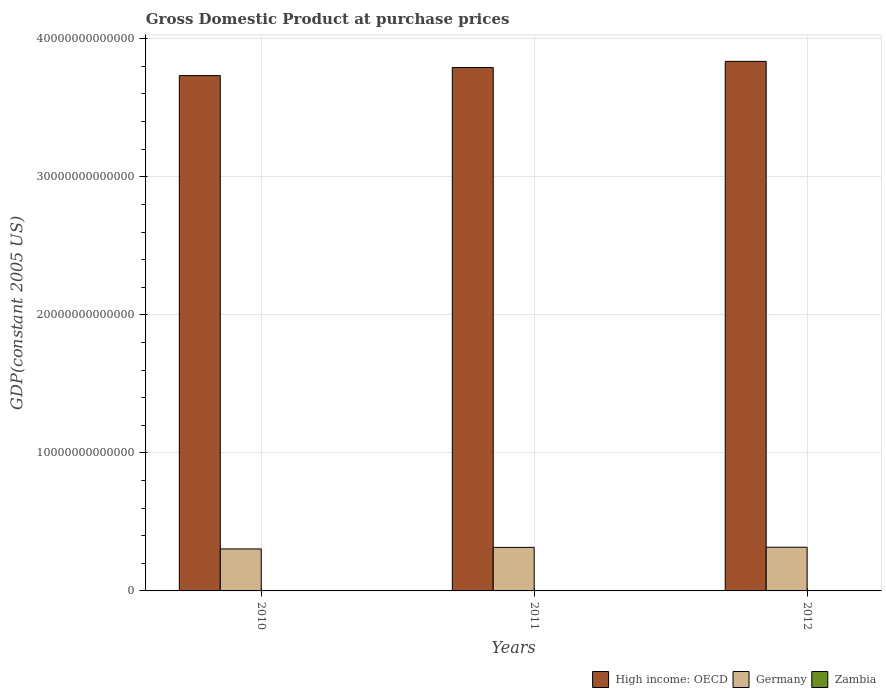How many different coloured bars are there?
Offer a very short reply. 3. Are the number of bars on each tick of the X-axis equal?
Give a very brief answer. Yes. What is the label of the 3rd group of bars from the left?
Your answer should be compact. 2012. In how many cases, is the number of bars for a given year not equal to the number of legend labels?
Offer a very short reply. 0. What is the GDP at purchase prices in Zambia in 2012?
Make the answer very short. 1.44e+1. Across all years, what is the maximum GDP at purchase prices in Zambia?
Provide a succinct answer. 1.44e+1. Across all years, what is the minimum GDP at purchase prices in Zambia?
Offer a terse response. 1.26e+1. What is the total GDP at purchase prices in High income: OECD in the graph?
Your answer should be very brief. 1.14e+14. What is the difference between the GDP at purchase prices in Germany in 2010 and that in 2011?
Your answer should be compact. -1.11e+11. What is the difference between the GDP at purchase prices in High income: OECD in 2011 and the GDP at purchase prices in Germany in 2012?
Provide a short and direct response. 3.48e+13. What is the average GDP at purchase prices in Zambia per year?
Your response must be concise. 1.35e+1. In the year 2011, what is the difference between the GDP at purchase prices in Germany and GDP at purchase prices in Zambia?
Ensure brevity in your answer.  3.14e+12. What is the ratio of the GDP at purchase prices in Germany in 2010 to that in 2012?
Offer a terse response. 0.96. Is the difference between the GDP at purchase prices in Germany in 2010 and 2011 greater than the difference between the GDP at purchase prices in Zambia in 2010 and 2011?
Give a very brief answer. No. What is the difference between the highest and the second highest GDP at purchase prices in Zambia?
Offer a terse response. 9.05e+08. What is the difference between the highest and the lowest GDP at purchase prices in High income: OECD?
Provide a short and direct response. 1.03e+12. Is the sum of the GDP at purchase prices in High income: OECD in 2011 and 2012 greater than the maximum GDP at purchase prices in Germany across all years?
Keep it short and to the point. Yes. What does the 2nd bar from the left in 2012 represents?
Provide a short and direct response. Germany. What does the 1st bar from the right in 2011 represents?
Offer a very short reply. Zambia. What is the difference between two consecutive major ticks on the Y-axis?
Provide a short and direct response. 1.00e+13. Does the graph contain grids?
Your answer should be very brief. Yes. Where does the legend appear in the graph?
Offer a terse response. Bottom right. How are the legend labels stacked?
Your answer should be very brief. Horizontal. What is the title of the graph?
Provide a short and direct response. Gross Domestic Product at purchase prices. What is the label or title of the Y-axis?
Make the answer very short. GDP(constant 2005 US). What is the GDP(constant 2005 US) in High income: OECD in 2010?
Ensure brevity in your answer.  3.73e+13. What is the GDP(constant 2005 US) in Germany in 2010?
Offer a terse response. 3.04e+12. What is the GDP(constant 2005 US) in Zambia in 2010?
Keep it short and to the point. 1.26e+1. What is the GDP(constant 2005 US) of High income: OECD in 2011?
Keep it short and to the point. 3.79e+13. What is the GDP(constant 2005 US) of Germany in 2011?
Your response must be concise. 3.15e+12. What is the GDP(constant 2005 US) of Zambia in 2011?
Keep it short and to the point. 1.34e+1. What is the GDP(constant 2005 US) of High income: OECD in 2012?
Offer a terse response. 3.84e+13. What is the GDP(constant 2005 US) in Germany in 2012?
Your answer should be very brief. 3.17e+12. What is the GDP(constant 2005 US) in Zambia in 2012?
Offer a terse response. 1.44e+1. Across all years, what is the maximum GDP(constant 2005 US) in High income: OECD?
Keep it short and to the point. 3.84e+13. Across all years, what is the maximum GDP(constant 2005 US) of Germany?
Give a very brief answer. 3.17e+12. Across all years, what is the maximum GDP(constant 2005 US) in Zambia?
Offer a very short reply. 1.44e+1. Across all years, what is the minimum GDP(constant 2005 US) in High income: OECD?
Provide a succinct answer. 3.73e+13. Across all years, what is the minimum GDP(constant 2005 US) of Germany?
Offer a very short reply. 3.04e+12. Across all years, what is the minimum GDP(constant 2005 US) in Zambia?
Ensure brevity in your answer.  1.26e+1. What is the total GDP(constant 2005 US) of High income: OECD in the graph?
Make the answer very short. 1.14e+14. What is the total GDP(constant 2005 US) of Germany in the graph?
Your response must be concise. 9.36e+12. What is the total GDP(constant 2005 US) of Zambia in the graph?
Your response must be concise. 4.05e+1. What is the difference between the GDP(constant 2005 US) in High income: OECD in 2010 and that in 2011?
Your response must be concise. -5.88e+11. What is the difference between the GDP(constant 2005 US) in Germany in 2010 and that in 2011?
Provide a short and direct response. -1.11e+11. What is the difference between the GDP(constant 2005 US) of Zambia in 2010 and that in 2011?
Your answer should be compact. -8.02e+08. What is the difference between the GDP(constant 2005 US) of High income: OECD in 2010 and that in 2012?
Ensure brevity in your answer.  -1.03e+12. What is the difference between the GDP(constant 2005 US) in Germany in 2010 and that in 2012?
Provide a succinct answer. -1.24e+11. What is the difference between the GDP(constant 2005 US) of Zambia in 2010 and that in 2012?
Provide a succinct answer. -1.71e+09. What is the difference between the GDP(constant 2005 US) in High income: OECD in 2011 and that in 2012?
Keep it short and to the point. -4.46e+11. What is the difference between the GDP(constant 2005 US) in Germany in 2011 and that in 2012?
Offer a terse response. -1.28e+1. What is the difference between the GDP(constant 2005 US) of Zambia in 2011 and that in 2012?
Your response must be concise. -9.05e+08. What is the difference between the GDP(constant 2005 US) of High income: OECD in 2010 and the GDP(constant 2005 US) of Germany in 2011?
Provide a succinct answer. 3.42e+13. What is the difference between the GDP(constant 2005 US) of High income: OECD in 2010 and the GDP(constant 2005 US) of Zambia in 2011?
Offer a terse response. 3.73e+13. What is the difference between the GDP(constant 2005 US) in Germany in 2010 and the GDP(constant 2005 US) in Zambia in 2011?
Provide a succinct answer. 3.03e+12. What is the difference between the GDP(constant 2005 US) in High income: OECD in 2010 and the GDP(constant 2005 US) in Germany in 2012?
Offer a very short reply. 3.42e+13. What is the difference between the GDP(constant 2005 US) of High income: OECD in 2010 and the GDP(constant 2005 US) of Zambia in 2012?
Ensure brevity in your answer.  3.73e+13. What is the difference between the GDP(constant 2005 US) in Germany in 2010 and the GDP(constant 2005 US) in Zambia in 2012?
Your answer should be compact. 3.03e+12. What is the difference between the GDP(constant 2005 US) of High income: OECD in 2011 and the GDP(constant 2005 US) of Germany in 2012?
Ensure brevity in your answer.  3.48e+13. What is the difference between the GDP(constant 2005 US) of High income: OECD in 2011 and the GDP(constant 2005 US) of Zambia in 2012?
Your response must be concise. 3.79e+13. What is the difference between the GDP(constant 2005 US) of Germany in 2011 and the GDP(constant 2005 US) of Zambia in 2012?
Ensure brevity in your answer.  3.14e+12. What is the average GDP(constant 2005 US) of High income: OECD per year?
Provide a short and direct response. 3.79e+13. What is the average GDP(constant 2005 US) in Germany per year?
Make the answer very short. 3.12e+12. What is the average GDP(constant 2005 US) of Zambia per year?
Ensure brevity in your answer.  1.35e+1. In the year 2010, what is the difference between the GDP(constant 2005 US) in High income: OECD and GDP(constant 2005 US) in Germany?
Keep it short and to the point. 3.43e+13. In the year 2010, what is the difference between the GDP(constant 2005 US) of High income: OECD and GDP(constant 2005 US) of Zambia?
Your response must be concise. 3.73e+13. In the year 2010, what is the difference between the GDP(constant 2005 US) in Germany and GDP(constant 2005 US) in Zambia?
Offer a terse response. 3.03e+12. In the year 2011, what is the difference between the GDP(constant 2005 US) of High income: OECD and GDP(constant 2005 US) of Germany?
Your answer should be very brief. 3.48e+13. In the year 2011, what is the difference between the GDP(constant 2005 US) of High income: OECD and GDP(constant 2005 US) of Zambia?
Your answer should be very brief. 3.79e+13. In the year 2011, what is the difference between the GDP(constant 2005 US) in Germany and GDP(constant 2005 US) in Zambia?
Provide a succinct answer. 3.14e+12. In the year 2012, what is the difference between the GDP(constant 2005 US) of High income: OECD and GDP(constant 2005 US) of Germany?
Provide a succinct answer. 3.52e+13. In the year 2012, what is the difference between the GDP(constant 2005 US) in High income: OECD and GDP(constant 2005 US) in Zambia?
Your response must be concise. 3.84e+13. In the year 2012, what is the difference between the GDP(constant 2005 US) of Germany and GDP(constant 2005 US) of Zambia?
Make the answer very short. 3.15e+12. What is the ratio of the GDP(constant 2005 US) in High income: OECD in 2010 to that in 2011?
Make the answer very short. 0.98. What is the ratio of the GDP(constant 2005 US) in Germany in 2010 to that in 2011?
Offer a very short reply. 0.96. What is the ratio of the GDP(constant 2005 US) of Zambia in 2010 to that in 2011?
Offer a terse response. 0.94. What is the ratio of the GDP(constant 2005 US) of High income: OECD in 2010 to that in 2012?
Ensure brevity in your answer.  0.97. What is the ratio of the GDP(constant 2005 US) of Germany in 2010 to that in 2012?
Keep it short and to the point. 0.96. What is the ratio of the GDP(constant 2005 US) of Zambia in 2010 to that in 2012?
Ensure brevity in your answer.  0.88. What is the ratio of the GDP(constant 2005 US) in High income: OECD in 2011 to that in 2012?
Provide a short and direct response. 0.99. What is the ratio of the GDP(constant 2005 US) of Zambia in 2011 to that in 2012?
Your response must be concise. 0.94. What is the difference between the highest and the second highest GDP(constant 2005 US) of High income: OECD?
Your response must be concise. 4.46e+11. What is the difference between the highest and the second highest GDP(constant 2005 US) of Germany?
Your answer should be compact. 1.28e+1. What is the difference between the highest and the second highest GDP(constant 2005 US) in Zambia?
Your response must be concise. 9.05e+08. What is the difference between the highest and the lowest GDP(constant 2005 US) in High income: OECD?
Your response must be concise. 1.03e+12. What is the difference between the highest and the lowest GDP(constant 2005 US) in Germany?
Offer a very short reply. 1.24e+11. What is the difference between the highest and the lowest GDP(constant 2005 US) of Zambia?
Offer a very short reply. 1.71e+09. 